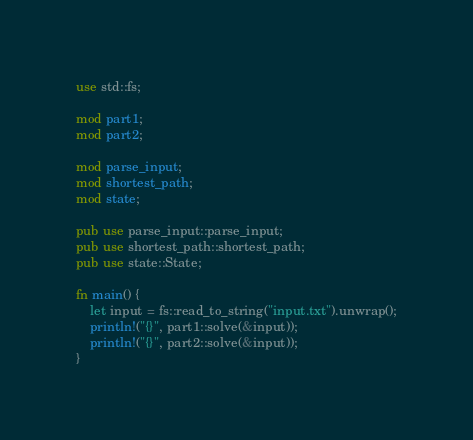Convert code to text. <code><loc_0><loc_0><loc_500><loc_500><_Rust_>use std::fs;

mod part1;
mod part2;

mod parse_input;
mod shortest_path;
mod state;

pub use parse_input::parse_input;
pub use shortest_path::shortest_path;
pub use state::State;

fn main() {
    let input = fs::read_to_string("input.txt").unwrap();
    println!("{}", part1::solve(&input));
    println!("{}", part2::solve(&input));
}
</code> 